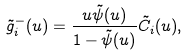Convert formula to latex. <formula><loc_0><loc_0><loc_500><loc_500>\tilde { g } _ { i } ^ { - } ( u ) = \frac { u \tilde { \psi } ( u ) } { 1 - \tilde { \psi } ( u ) } \tilde { C } _ { i } ( u ) ,</formula> 